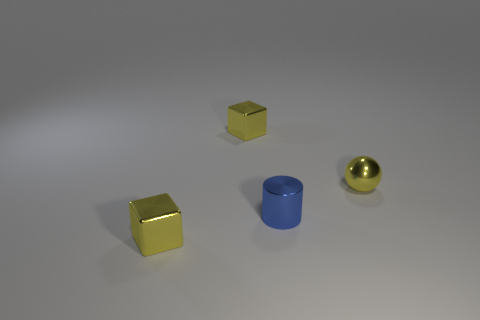Add 2 small blue metallic objects. How many objects exist? 6 Subtract all balls. How many objects are left? 3 Subtract 0 cyan cylinders. How many objects are left? 4 Subtract all yellow objects. Subtract all small metal balls. How many objects are left? 0 Add 1 tiny yellow objects. How many tiny yellow objects are left? 4 Add 3 yellow things. How many yellow things exist? 6 